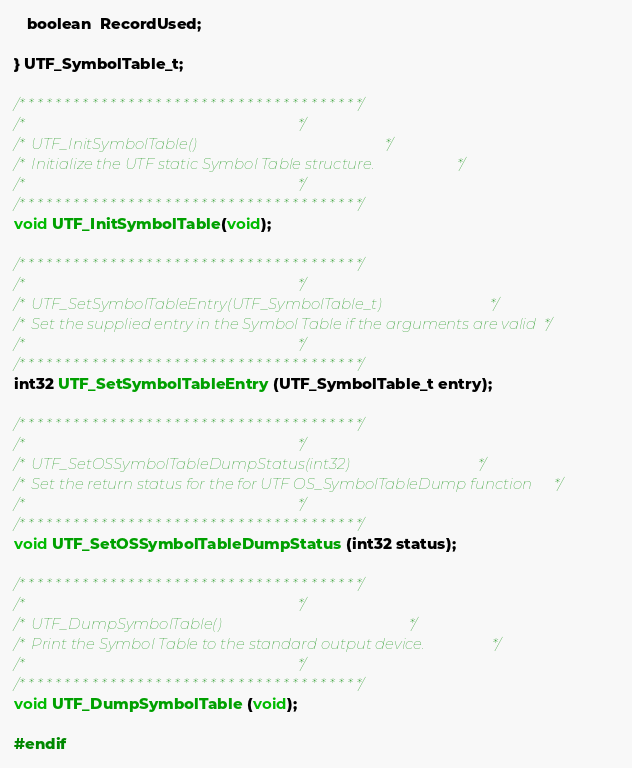<code> <loc_0><loc_0><loc_500><loc_500><_C_>   boolean  RecordUsed;

} UTF_SymbolTable_t;

/* * * * * * * * * * * * * * * * * * * * * * * * * * * * * * * * * * * * * */
/*                                                                         */
/*  UTF_InitSymbolTable()                                                  */
/*  Initialize the UTF static Symbol Table structure.                      */
/*                                                                         */
/* * * * * * * * * * * * * * * * * * * * * * * * * * * * * * * * * * * * * */
void UTF_InitSymbolTable(void);

/* * * * * * * * * * * * * * * * * * * * * * * * * * * * * * * * * * * * * */
/*                                                                         */
/*  UTF_SetSymbolTableEntry(UTF_SymbolTable_t)                             */
/*  Set the supplied entry in the Symbol Table if the arguments are valid  */
/*                                                                         */
/* * * * * * * * * * * * * * * * * * * * * * * * * * * * * * * * * * * * * */
int32 UTF_SetSymbolTableEntry (UTF_SymbolTable_t entry);

/* * * * * * * * * * * * * * * * * * * * * * * * * * * * * * * * * * * * * */
/*                                                                         */
/*  UTF_SetOSSymbolTableDumpStatus(int32)                                  */
/*  Set the return status for the for UTF OS_SymbolTableDump function      */
/*                                                                         */
/* * * * * * * * * * * * * * * * * * * * * * * * * * * * * * * * * * * * * */
void UTF_SetOSSymbolTableDumpStatus (int32 status);

/* * * * * * * * * * * * * * * * * * * * * * * * * * * * * * * * * * * * * */
/*                                                                         */
/*  UTF_DumpSymbolTable()                                                  */
/*  Print the Symbol Table to the standard output device.                  */
/*                                                                         */
/* * * * * * * * * * * * * * * * * * * * * * * * * * * * * * * * * * * * * */
void UTF_DumpSymbolTable (void);

#endif
</code> 